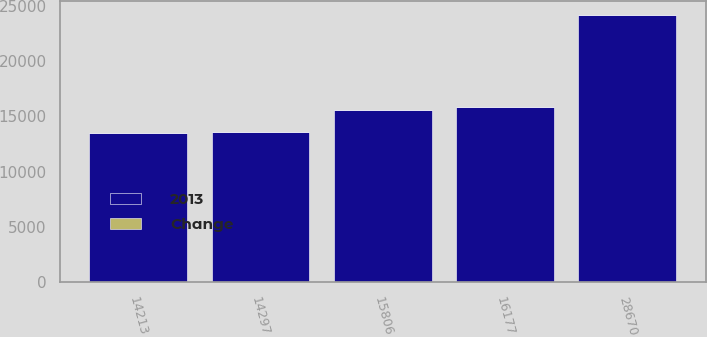Convert chart. <chart><loc_0><loc_0><loc_500><loc_500><stacked_bar_chart><ecel><fcel>14213<fcel>28670<fcel>14297<fcel>16177<fcel>15806<nl><fcel>2013<fcel>13514<fcel>24155<fcel>13566<fcel>15806<fcel>15601<nl><fcel>Change<fcel>5<fcel>19<fcel>5<fcel>2<fcel>1<nl></chart> 